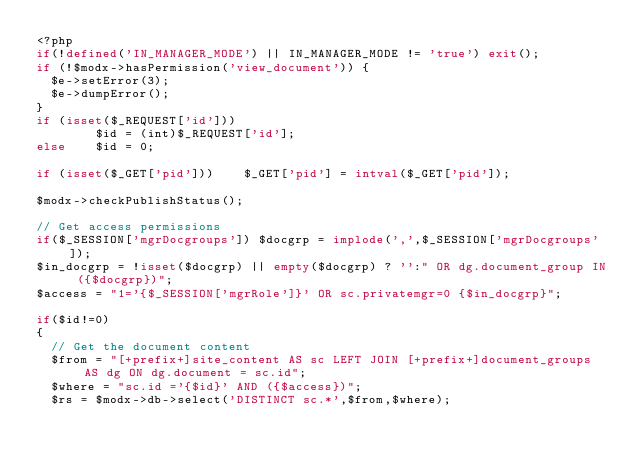<code> <loc_0><loc_0><loc_500><loc_500><_PHP_><?php
if(!defined('IN_MANAGER_MODE') || IN_MANAGER_MODE != 'true') exit();
if (!$modx->hasPermission('view_document')) {
	$e->setError(3);
	$e->dumpError();
}
if (isset($_REQUEST['id']))
        $id = (int)$_REQUEST['id'];
else    $id = 0;

if (isset($_GET['pid']))    $_GET['pid'] = intval($_GET['pid']);

$modx->checkPublishStatus();

// Get access permissions
if($_SESSION['mgrDocgroups']) $docgrp = implode(',',$_SESSION['mgrDocgroups']);
$in_docgrp = !isset($docgrp) || empty($docgrp) ? '':" OR dg.document_group IN ({$docgrp})";
$access = "1='{$_SESSION['mgrRole']}' OR sc.privatemgr=0 {$in_docgrp}";

if($id!=0)
{
	// Get the document content
	$from = "[+prefix+]site_content AS sc LEFT JOIN [+prefix+]document_groups AS dg ON dg.document = sc.id";
	$where = "sc.id ='{$id}' AND ({$access})";
	$rs = $modx->db->select('DISTINCT sc.*',$from,$where);</code> 